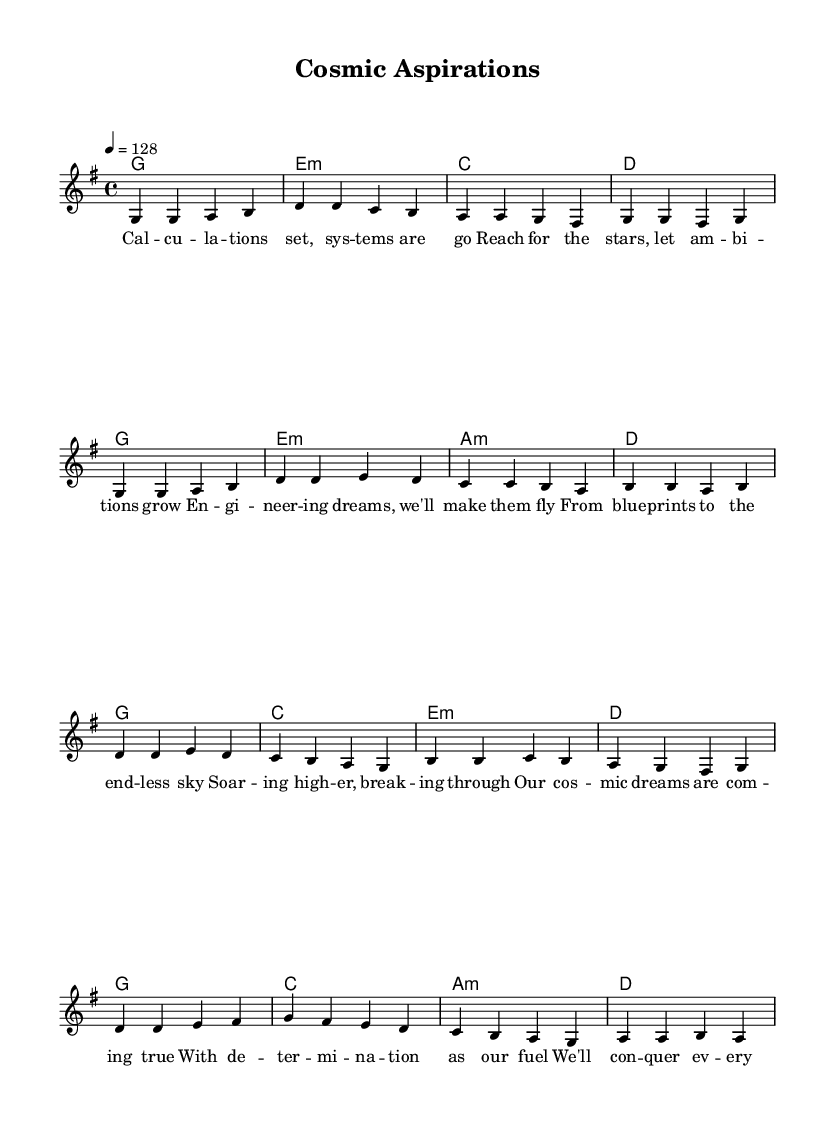What is the key signature of this music? The key signature is G major, indicated by one sharp (F#) at the beginning of the staff.
Answer: G major What is the time signature of the piece? The time signature is 4/4, which means there are four beats in each measure and a quarter note gets one beat.
Answer: 4/4 What is the tempo marking for this score? The tempo marking is 128 beats per minute, suggesting a moderate to fast pace.
Answer: 128 How many measures are in the verse section? The verse section contains 8 measures, as indicated by the structure of the melody and lyrics arranged above it.
Answer: 8 What type of harmony is used in the verse? The harmony in the verse primarily consists of major and minor chords, which are typical in K-Pop music to create an appealing sound.
Answer: Major and minor chords What is the primary theme of the lyrics? The primary theme of the lyrics revolves around aspirations, dreams, and engineering success, reflecting an ambitious message typical of K-Pop.
Answer: Aspirations and dreams How do the lyrics in the chorus differ from those in the verse? The lyrics in the chorus are more uplifting and triumphant, emphasizing achieving dreams compared to the more descriptive verse.
Answer: Uplifting and triumphant 